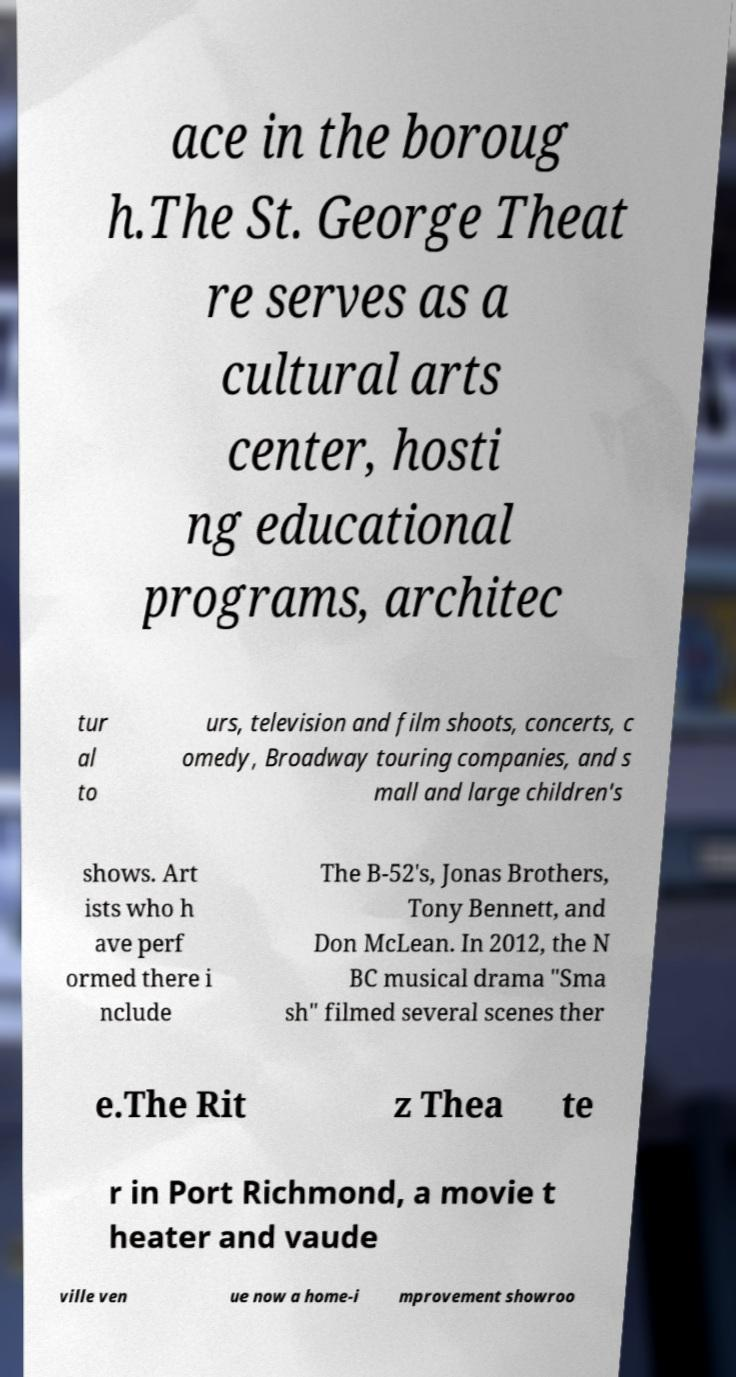For documentation purposes, I need the text within this image transcribed. Could you provide that? ace in the boroug h.The St. George Theat re serves as a cultural arts center, hosti ng educational programs, architec tur al to urs, television and film shoots, concerts, c omedy, Broadway touring companies, and s mall and large children's shows. Art ists who h ave perf ormed there i nclude The B-52's, Jonas Brothers, Tony Bennett, and Don McLean. In 2012, the N BC musical drama "Sma sh" filmed several scenes ther e.The Rit z Thea te r in Port Richmond, a movie t heater and vaude ville ven ue now a home-i mprovement showroo 